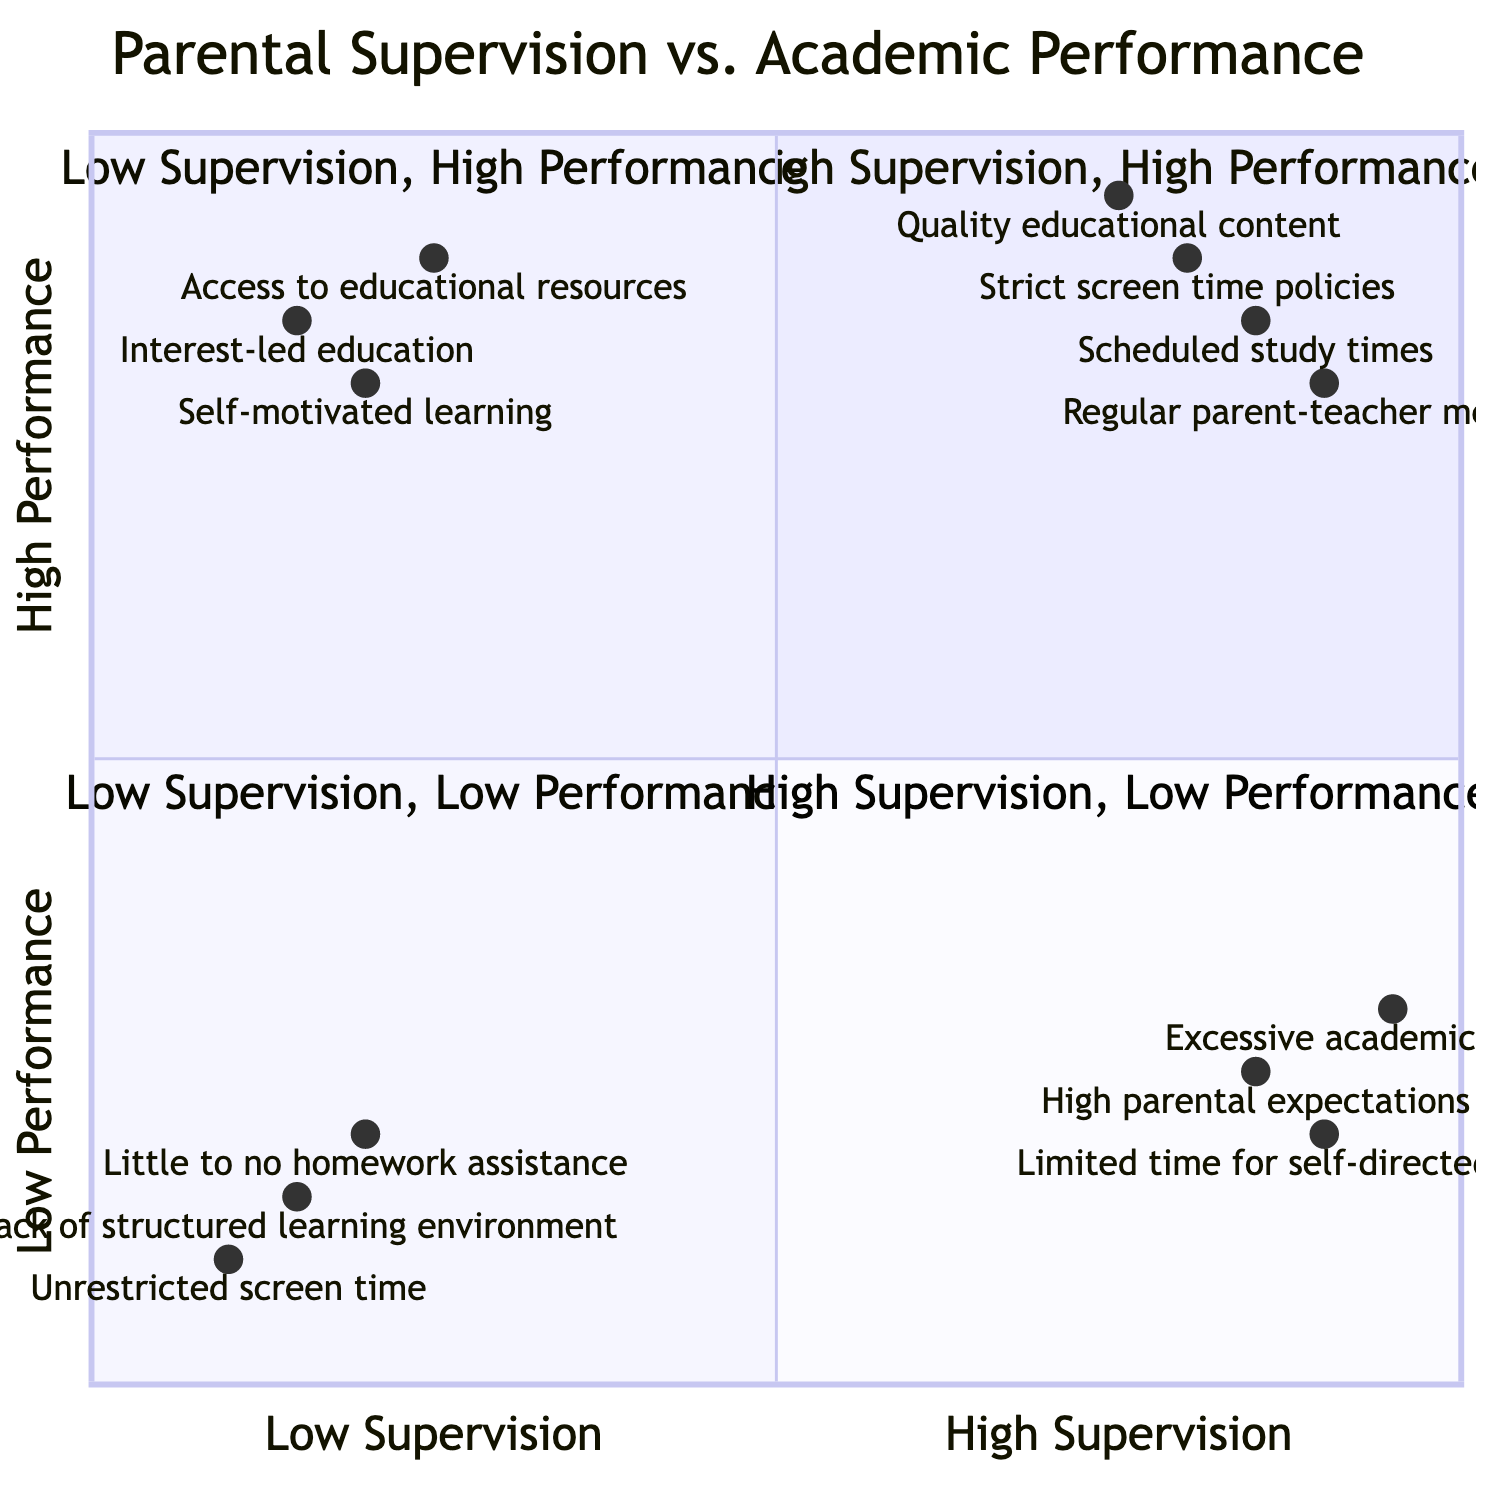What is the definition of the "High Supervision, High Performance" quadrant? This quadrant describes children who receive high levels of parental supervision and achieve high academic performance, often indicated by practices like strict screen time policies and scheduled study times.
Answer: High Supervision, High Performance How many examples are given for "Low Supervision, Low Performance"? There are three examples provided in this quadrant, including unrestricted screen time, lack of structured learning environment, and little to no homework assistance.
Answer: Three Which quadrant contains the example "Excessive academic pressure"? This example is found in the "High Supervision, Low Performance" quadrant, indicating a situation where children are closely monitored but still struggle academically due to high pressure.
Answer: High Supervision, Low Performance What percentage of the quadrant information indicates "Self-motivated learning"? The quadrant for "Low Supervision, High Performance" contains this example, which illustrates children who thrive academically without much supervision.
Answer: Low Supervision, High Performance In which quadrant would you categorize children with "Quality educational content"? This example belongs to the "High Supervision, High Performance" quadrant, showcasing a positive element of parental oversight that leads to better academic results.
Answer: High Supervision, High Performance Which quadrant has the least strict parental supervision? The "Low Supervision, Low Performance" quadrant represents children who experience minimal parental oversight and generally have low academic performance.
Answer: Low Supervision, Low Performance How do "Limited time for self-directed learning" and "High parental expectations" relate in this chart? Both examples are located in the "High Supervision, Low Performance" quadrant, indicating that excessive supervision can hinder self-directed learning and create unrealistic expectations, leading to poor academic outcomes.
Answer: High Supervision, Low Performance What do the terms "Interest-led education" and "Access to educational resources" demonstrate? These terms are examples in the "Low Supervision, High Performance" quadrant, representing effective learning that occurs when children are given the freedom to explore their interests and utilize available resources, resulting in high academic performance despite lower supervision.
Answer: Low Supervision, High Performance 